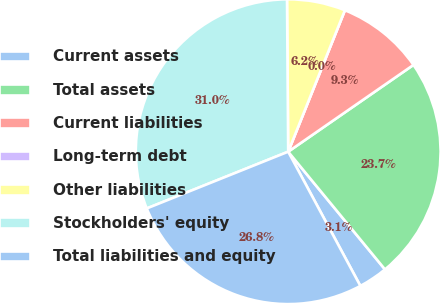<chart> <loc_0><loc_0><loc_500><loc_500><pie_chart><fcel>Current assets<fcel>Total assets<fcel>Current liabilities<fcel>Long-term debt<fcel>Other liabilities<fcel>Stockholders' equity<fcel>Total liabilities and equity<nl><fcel>3.1%<fcel>23.69%<fcel>9.29%<fcel>0.0%<fcel>6.19%<fcel>30.95%<fcel>26.78%<nl></chart> 